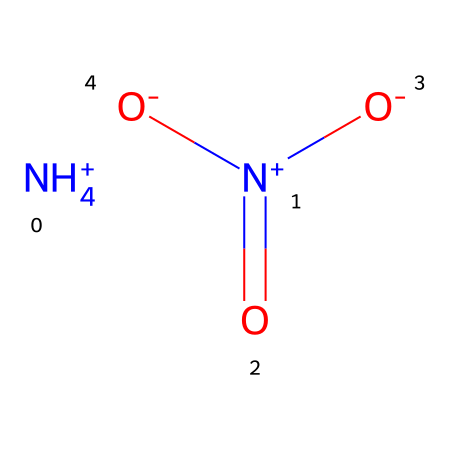What is the molecular formula of ammonium nitrate? The molecular formula can be derived from the SMILES representation, identifying the elements present. In this case, there are one nitrogen atom from ammonium and one nitrogen from nitrate, four hydrogen atoms, three oxygen atoms, resulting in the formula NH4NO3.
Answer: NH4NO3 How many nitrogen atoms are present in ammonium nitrate? Examining the SMILES structure shows one nitrogen in the ammonium ion and one nitrogen in the nitrate ion, totaling two nitrogen atoms.
Answer: 2 What type of bonding is present within ammonium nitrate? The molecule features ionic bonding between the positively charged ammonium ion and the negatively charged nitrate ion, alongside covalent bonding within the ammonium and nitrate ions themselves.
Answer: ionic and covalent Is ammonium nitrate a solid at room temperature? Chemical compounds like ammonium nitrate typically have defined melting points, and it is known to be a solid at standard room temperature due to its crystalline structure.
Answer: yes What functional groups are present in ammonium nitrate? The SMILES indicates the presence of an ammonium group (NH4+) and a nitrate group (NO3-), which are characteristic functional groups in the compound.
Answer: ammonium and nitrate Can ammonium nitrate act as an explosive? The chemical structure contains a combination of nitrogen and oxygen, which contributes to its potential as an explosive, especially under specific conditions, such as high heat or shock.
Answer: yes 